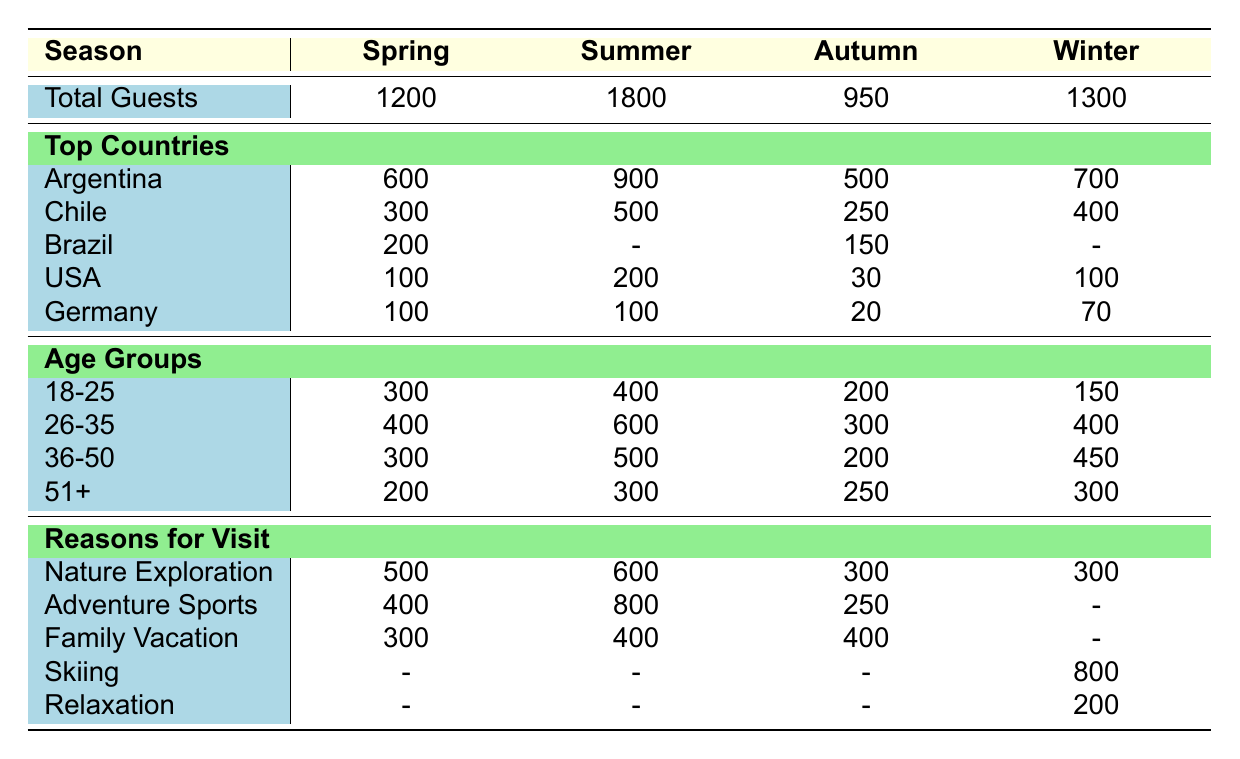What is the total number of guests in Summer? The table shows that the total number of guests in Summer is listed directly under the Summer column, which is 1800.
Answer: 1800 Which age group had the highest number of guests in Winter? In the Winter section, the Age Groups are displayed, and the highest number of guests is found in the 36-50 age group with 450 guests.
Answer: 36-50 How many guests came from Brazil in Autumn? The table indicates that in Autumn, the number of guests from Brazil is 150, which is recorded in the "Top Countries" section for that season.
Answer: 150 Which reason for visit had the lowest number of guests in Spring? In the "Reasons for Visit" section for Spring, the lowest number is recorded for "Family Vacation," with 300 guests, compared to others like "Nature Exploration" with 500 and "Adventure Sports" with 400.
Answer: Family Vacation How many guests are there across all seasons combined? To find the total number of guests, we sum the guests from each season: 1200 (Spring) + 1800 (Summer) + 950 (Autumn) + 1300 (Winter) = 4250.
Answer: 4250 Is the total number of guests in Autumn greater than that in Spring? The total number of guests in Autumn is 950 and in Spring is 1200. Since 950 is not greater than 1200, the statement is false.
Answer: No Which country contributed the second highest number of guests in Summer? From the Summer section, the highest contributor is Argentina with 900 guests, and the second highest is Chile with 500 guests, according to the data presented.
Answer: Chile What is the average number of guests from the USA across all seasons? The guest numbers from the USA are: 100 (Spring) + 200 (Summer) + 30 (Autumn) + 100 (Winter) = 430. There are 4 seasons, so the average is 430 / 4 = 107.5.
Answer: 107.5 Did the number of guests for "Adventure Sports" increase from Spring to Summer? In Spring, the guests for "Adventure Sports" are 400, while in Summer, they are 800. This shows an increase of 400 guests from Spring to Summer, indicating the answer is yes.
Answer: Yes 